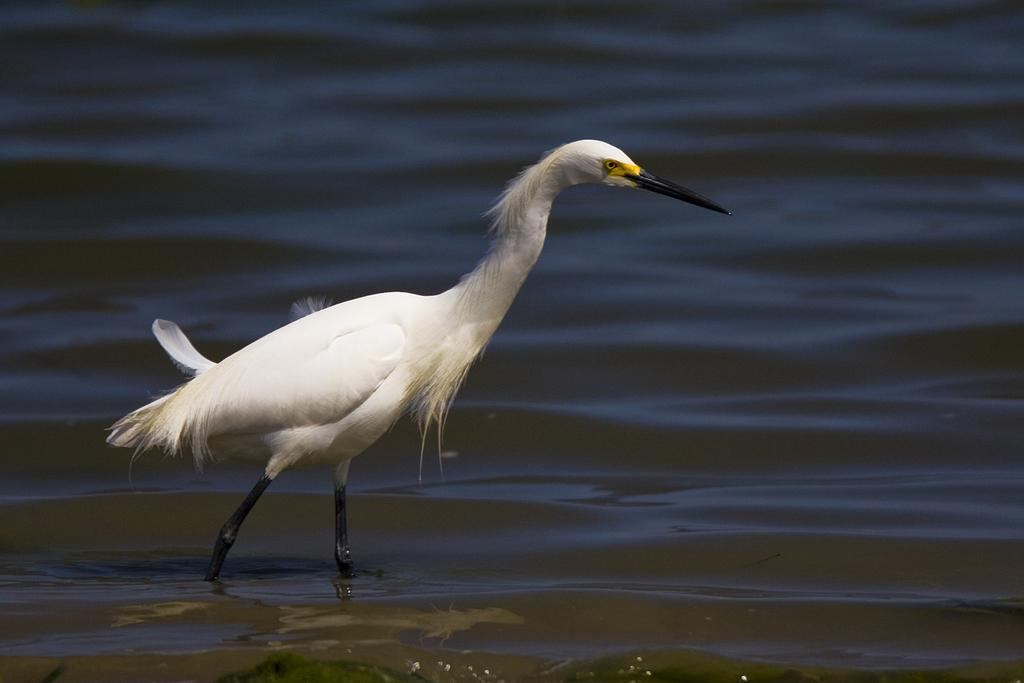What animal is present in the image? There is a duck in the image. Where is the duck located? The duck is on the water. What type of mask is the duck wearing in the image? There is no mask present on the duck in the image. What attraction is the duck visiting in the image? There is no indication of an attraction in the image; it simply shows a duck on the water. 